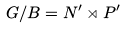Convert formula to latex. <formula><loc_0><loc_0><loc_500><loc_500>G / B = N ^ { \prime } \rtimes P ^ { \prime }</formula> 